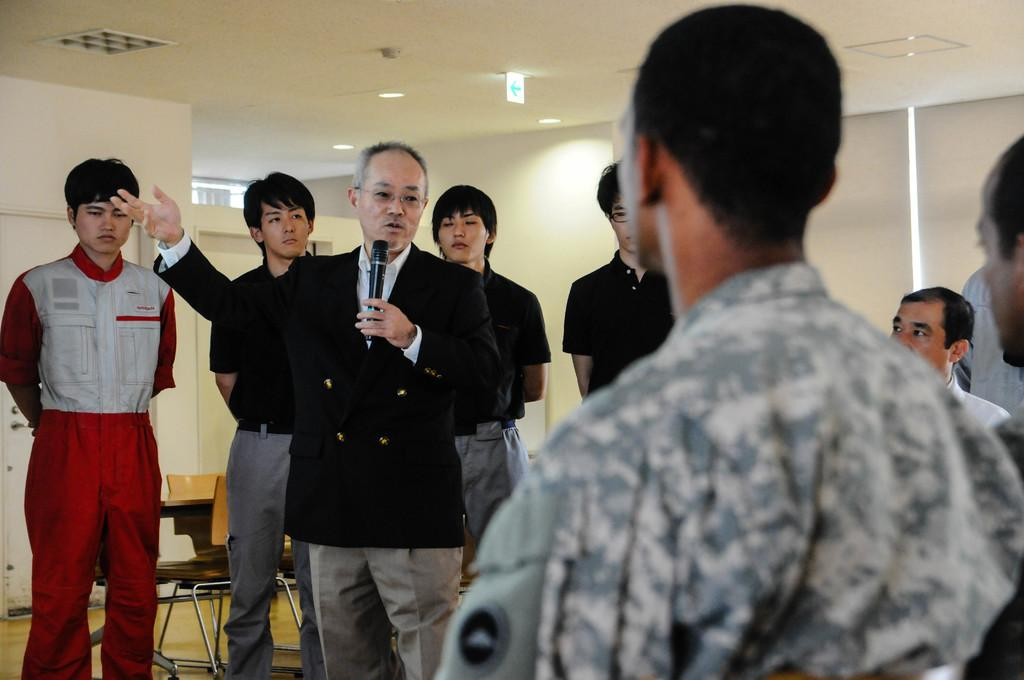How many people are in the image? There is a group of people in the image. What is one person doing in the image? One person is holding a microphone. What can be seen in the background of the image? There is a wall and a roof in the background of the image. What type of knot is being tied by the person holding the scissors in the image? There are no scissors or knots present in the image. What kind of hat is the person wearing in the image? There is no hat visible on any person in the image. 